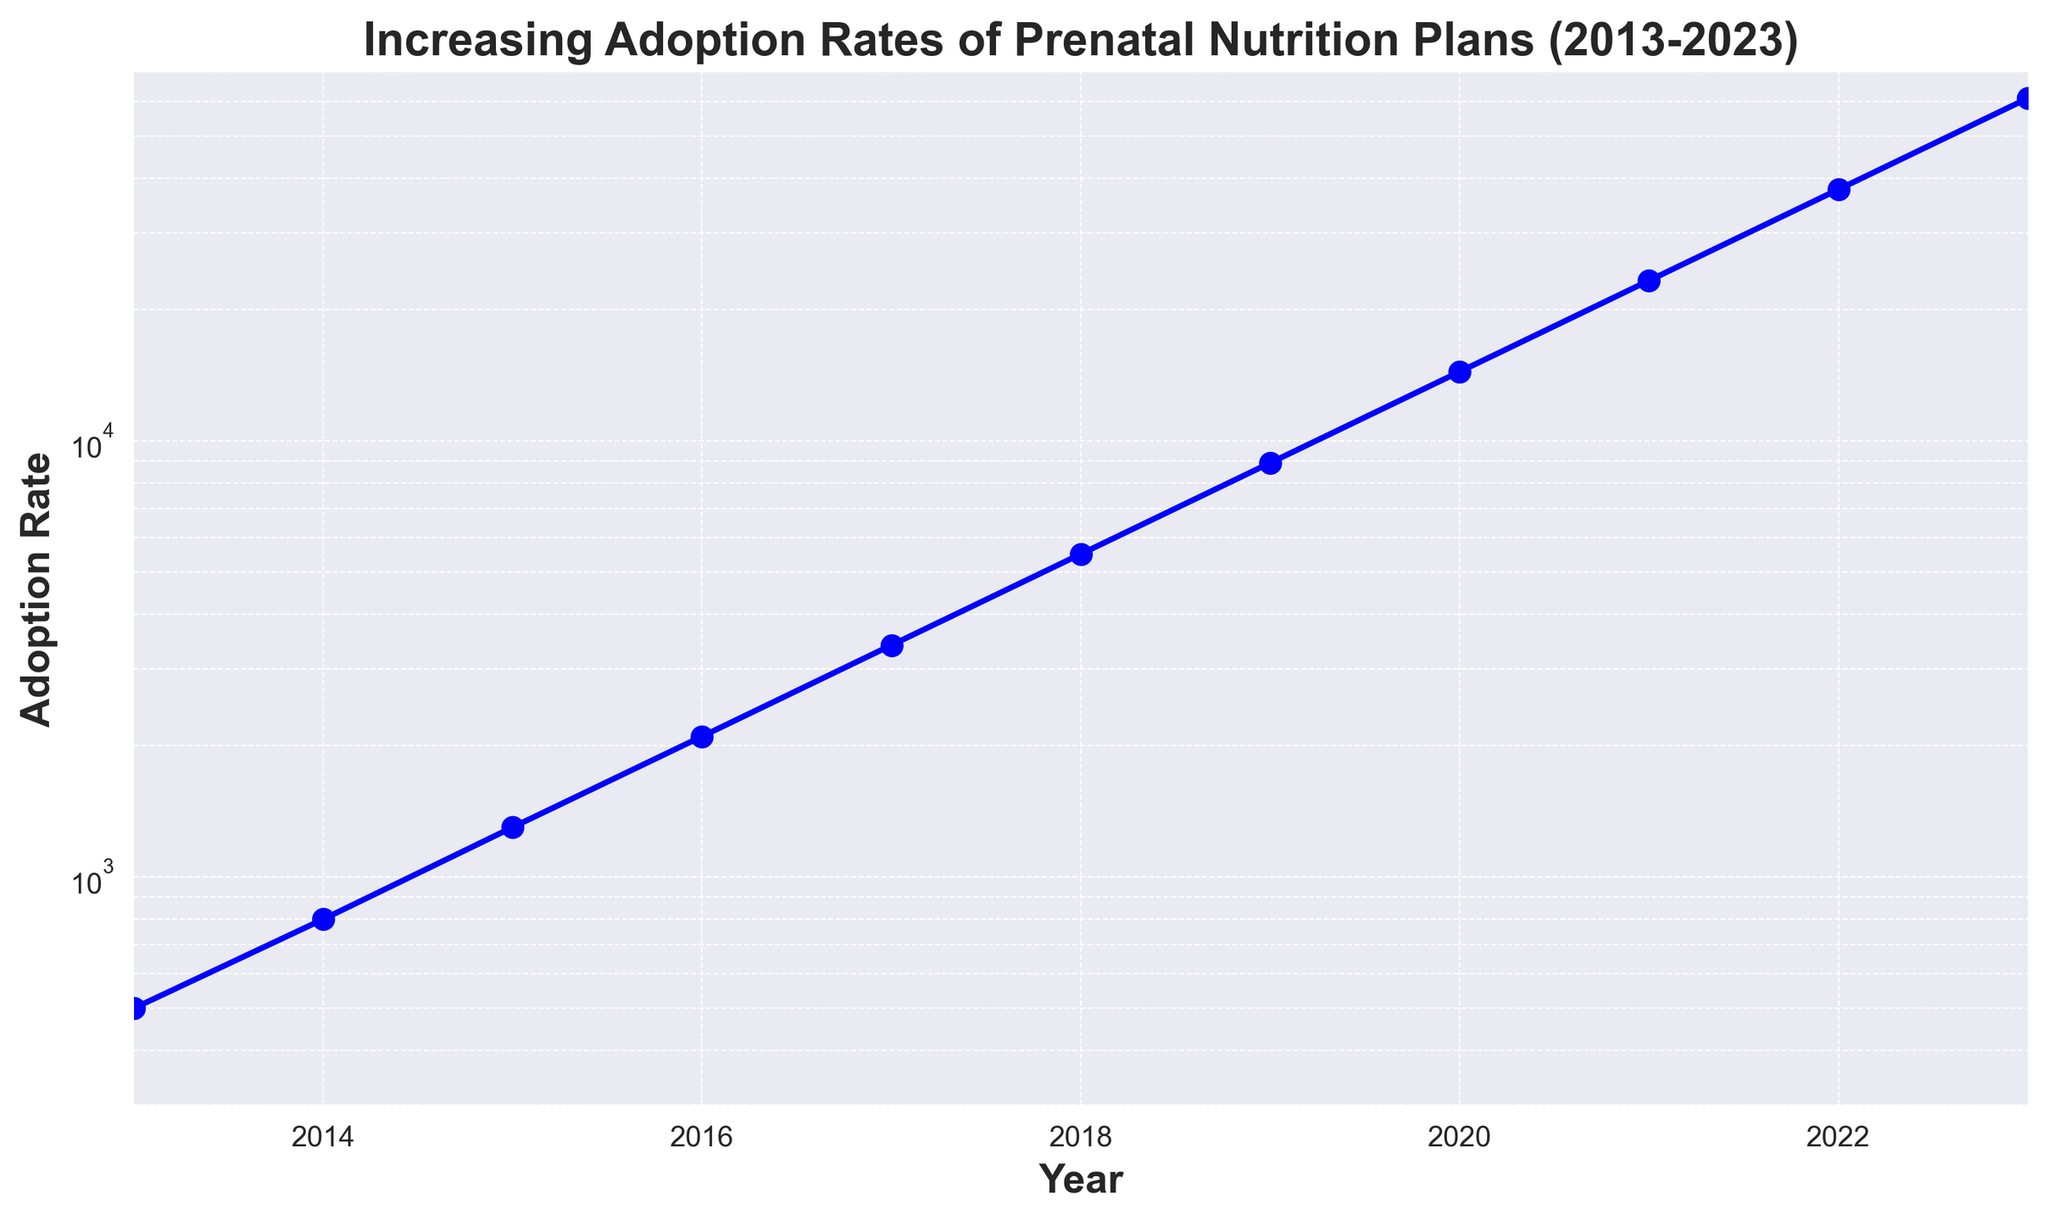How did the adoption rate of prenatal nutrition plans change between 2016 and 2020? To find the change, subtract the adoption rate in 2016 from that in 2020. The 2016 rate is 2100 and the 2020 rate is 14400. The change is 14400 - 2100 = 12300.
Answer: 12300 Between which consecutive years did the adoption rate experience the highest increase? Calculate the difference for each consecutive year and compare. The differences are as follows: 300 (2013-2014), 500 (2014-2015), 800 (2015-2016), 1300 (2016-2017), 2100 (2017-2018), 3400 (2018-2019), 5500 (2019-2020), 8900 (2020-2021), 14400 (2021-2022), and 23300 (2022-2023). The highest increase is 23300 between 2022 and 2023.
Answer: 2022 and 2023 What's the average adoption rate from 2017 to 2019? Calculate the average by summing the rates for 2017, 2018, and 2019, and then dividing by 3. The sum is 3400 + 5500 + 8900 = 17800. The average is 17800 / 3 ≈ 5933.33.
Answer: 5933.33 Between which years did the adoption rate double? To double, the rate in subsequent years should be approximately twice the previous year's rate. The 2013 rate is 500, and the 2014 rate is 800 (not double), the 2014 rate is 800, and the 2015 rate is 1300 (not double). The 2015 rate is 1300, and the 2016 rate is 2100 (approximately double but not beyond 100%). The only noticeable doubling is from 2018 (5500) to 2019 (8900) which is approximately 1.618 times. After that, from 2022 (37700) to 2023 (61000) almost doubling.
Answer: 2022 and 2023 What was the adoption rate three years after 2015? To find the adoption rate three years after 2015, look at the rate in 2018. The rate in 2018 is 5500.
Answer: 5500 What was the lowest adoption rate from 2013 to 2023, and in which year did it occur? The lowest rate from 2013 to 2023 can be seen at the starting point of the data. The rate in 2013 is 500, which is the lowest.
Answer: 500 in 2013 